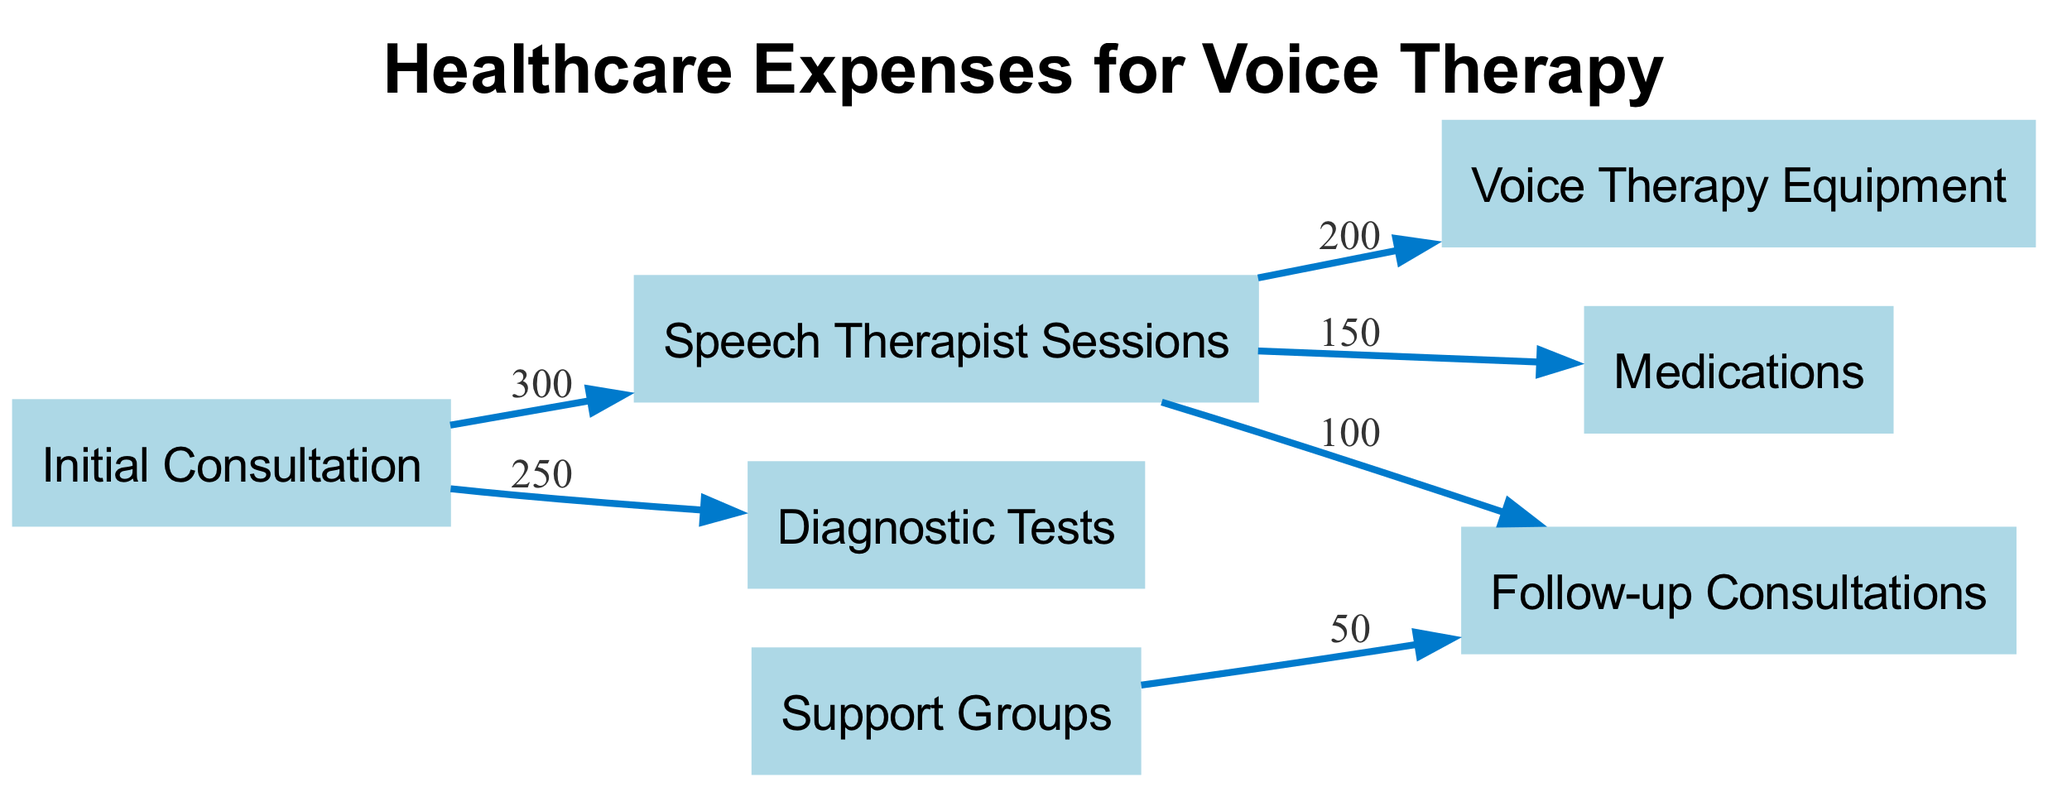What is the cost of the Initial Consultation? The cost of the Initial Consultation is found at the beginning of the flow in the diagram. The connected edge leading out from "Initial Consultation" shows the value of 300.
Answer: 300 How many nodes are represented in the diagram? To find the number of nodes, we count every unique entry in the "nodes" section of the provided data. There are 7 nodes listed, which include different aspects of healthcare expenses.
Answer: 7 What is the total cost of Speech Therapist Sessions connecting to Voice Therapy Equipment and Medications? The flow indicates that both "Voice Therapy Equipment" and "Medications" are connected directly to "Speech Therapist Sessions." Each has a respective value of 200 and 150. Summing these gives 200 + 150 = 350.
Answer: 350 Which node has a direct connection to both Follow-up Consultations and Speech Therapist Sessions? Looking at the relationships outlined in the links, we can see that "Speech Therapist Sessions" connects to "Follow-up Consultations." The question refers to identifying the node that connects to both, and "Speech Therapist Sessions" is the only node fitting this description.
Answer: Speech Therapist Sessions What is the value associated with the link between Support Groups and Follow-up Consultations? To answer this, we locate the edge in the diagram connecting "Support Groups" to "Follow-up Consultations." The corresponding value on that edge is indicated as 50.
Answer: 50 How much does the entire diagnostic process cost starting from the Initial Consultation? The "Initial Consultation" leads to "Diagnostic Tests," which is shown with a value of 250. Since it flows directly from the initial point, the total cost for the diagnostic process is simply the value associated with that edge.
Answer: 250 What is the cumulative value from Initial Consultation to Speech Therapist Sessions? For this, we check the flow from the "Initial Consultation." It leads directly to the "Speech Therapist Sessions," which has a cost of 300, representing the cumulative total from the start.
Answer: 300 What is the primary function of the initial node in the diagram? The diagram begins with the "Initial Consultation," which serves as the first step in the healthcare expense process related to voice therapy. Its function is to initiate the healthcare pathway.
Answer: Initial Consultation 